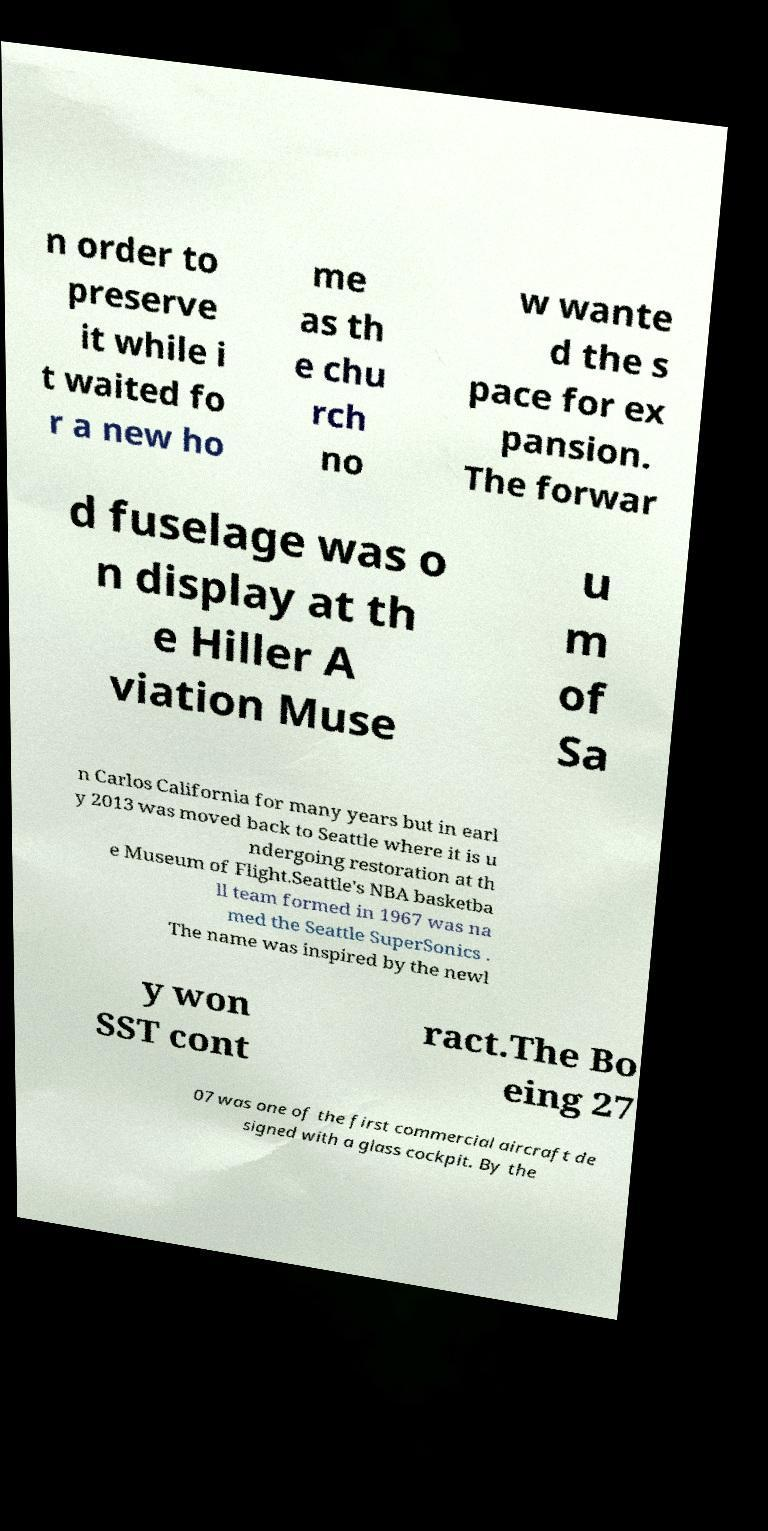What messages or text are displayed in this image? I need them in a readable, typed format. n order to preserve it while i t waited fo r a new ho me as th e chu rch no w wante d the s pace for ex pansion. The forwar d fuselage was o n display at th e Hiller A viation Muse u m of Sa n Carlos California for many years but in earl y 2013 was moved back to Seattle where it is u ndergoing restoration at th e Museum of Flight.Seattle's NBA basketba ll team formed in 1967 was na med the Seattle SuperSonics . The name was inspired by the newl y won SST cont ract.The Bo eing 27 07 was one of the first commercial aircraft de signed with a glass cockpit. By the 